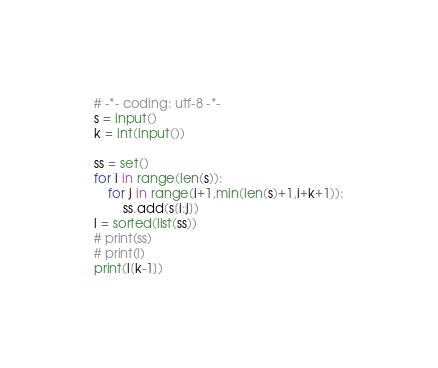Convert code to text. <code><loc_0><loc_0><loc_500><loc_500><_Python_># -*- coding: utf-8 -*-
s = input()
k = int(input())

ss = set()
for i in range(len(s)):
    for j in range(i+1,min(len(s)+1,i+k+1)):
        ss.add(s[i:j])
l = sorted(list(ss))
# print(ss)
# print(l)
print(l[k-1])
</code> 